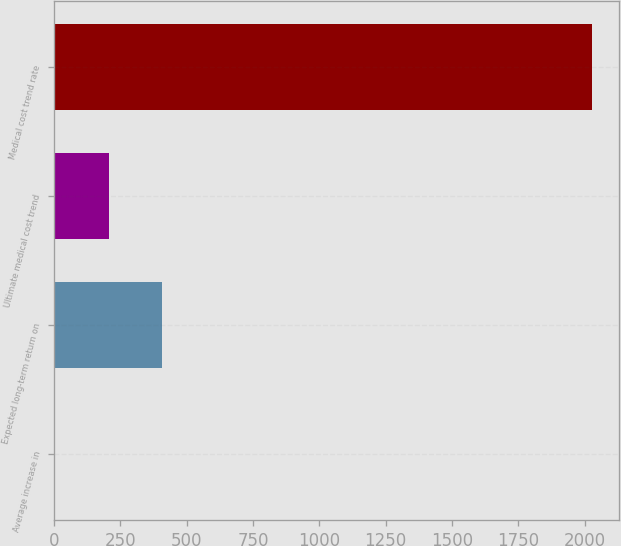Convert chart to OTSL. <chart><loc_0><loc_0><loc_500><loc_500><bar_chart><fcel>Average increase in<fcel>Expected long-term return on<fcel>Ultimate medical cost trend<fcel>Medical cost trend rate<nl><fcel>3.5<fcel>408.4<fcel>205.95<fcel>2028<nl></chart> 